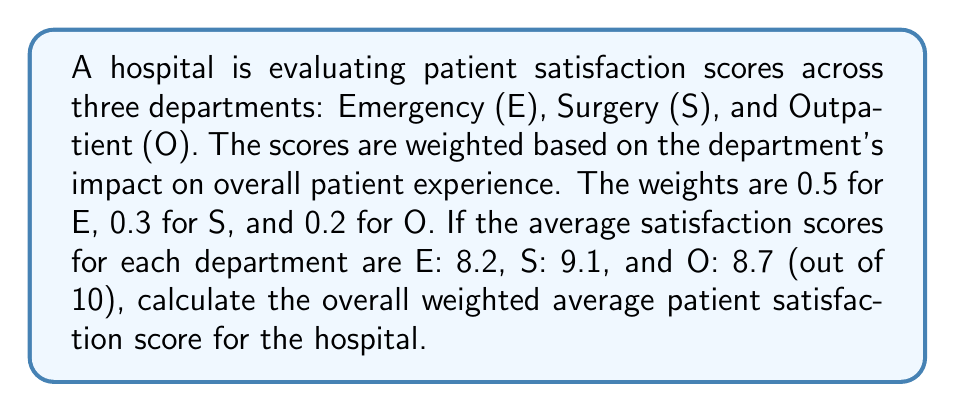Can you solve this math problem? To calculate the weighted average patient satisfaction score, we need to:

1. Multiply each department's score by its corresponding weight
2. Sum these weighted scores
3. Divide by the sum of the weights (which should equal 1)

Let's break it down step-by-step:

1. Calculate weighted scores:
   - Emergency (E): $0.5 \times 8.2 = 4.1$
   - Surgery (S): $0.3 \times 9.1 = 2.73$
   - Outpatient (O): $0.2 \times 8.7 = 1.74$

2. Sum the weighted scores:
   $$4.1 + 2.73 + 1.74 = 8.57$$

3. Verify that the sum of weights equals 1:
   $$0.5 + 0.3 + 0.2 = 1$$

4. Calculate the weighted average:
   $$\text{Weighted Average} = \frac{\sum \text{(Weight } \times \text{ Score)}}{\sum \text{Weights}}$$
   $$= \frac{4.1 + 2.73 + 1.74}{1} = 8.57$$

Therefore, the overall weighted average patient satisfaction score is 8.57 out of 10.
Answer: $8.57$ out of 10 